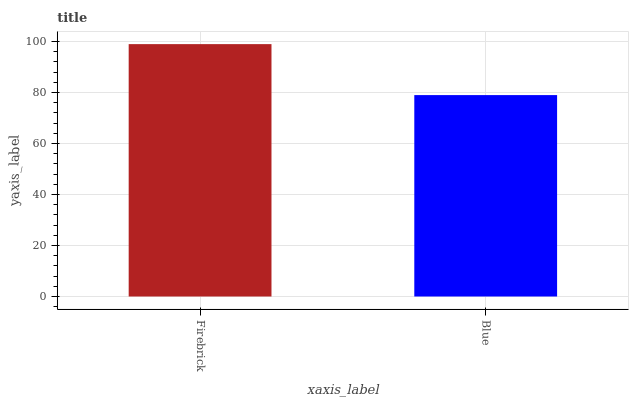Is Blue the minimum?
Answer yes or no. Yes. Is Firebrick the maximum?
Answer yes or no. Yes. Is Blue the maximum?
Answer yes or no. No. Is Firebrick greater than Blue?
Answer yes or no. Yes. Is Blue less than Firebrick?
Answer yes or no. Yes. Is Blue greater than Firebrick?
Answer yes or no. No. Is Firebrick less than Blue?
Answer yes or no. No. Is Firebrick the high median?
Answer yes or no. Yes. Is Blue the low median?
Answer yes or no. Yes. Is Blue the high median?
Answer yes or no. No. Is Firebrick the low median?
Answer yes or no. No. 